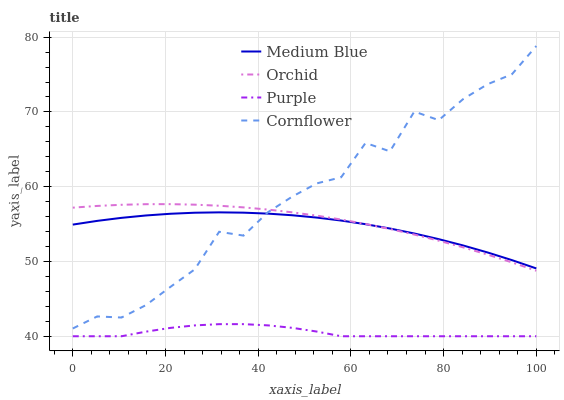Does Purple have the minimum area under the curve?
Answer yes or no. Yes. Does Cornflower have the maximum area under the curve?
Answer yes or no. Yes. Does Medium Blue have the minimum area under the curve?
Answer yes or no. No. Does Medium Blue have the maximum area under the curve?
Answer yes or no. No. Is Orchid the smoothest?
Answer yes or no. Yes. Is Cornflower the roughest?
Answer yes or no. Yes. Is Medium Blue the smoothest?
Answer yes or no. No. Is Medium Blue the roughest?
Answer yes or no. No. Does Purple have the lowest value?
Answer yes or no. Yes. Does Cornflower have the lowest value?
Answer yes or no. No. Does Cornflower have the highest value?
Answer yes or no. Yes. Does Medium Blue have the highest value?
Answer yes or no. No. Is Purple less than Orchid?
Answer yes or no. Yes. Is Medium Blue greater than Purple?
Answer yes or no. Yes. Does Orchid intersect Medium Blue?
Answer yes or no. Yes. Is Orchid less than Medium Blue?
Answer yes or no. No. Is Orchid greater than Medium Blue?
Answer yes or no. No. Does Purple intersect Orchid?
Answer yes or no. No. 